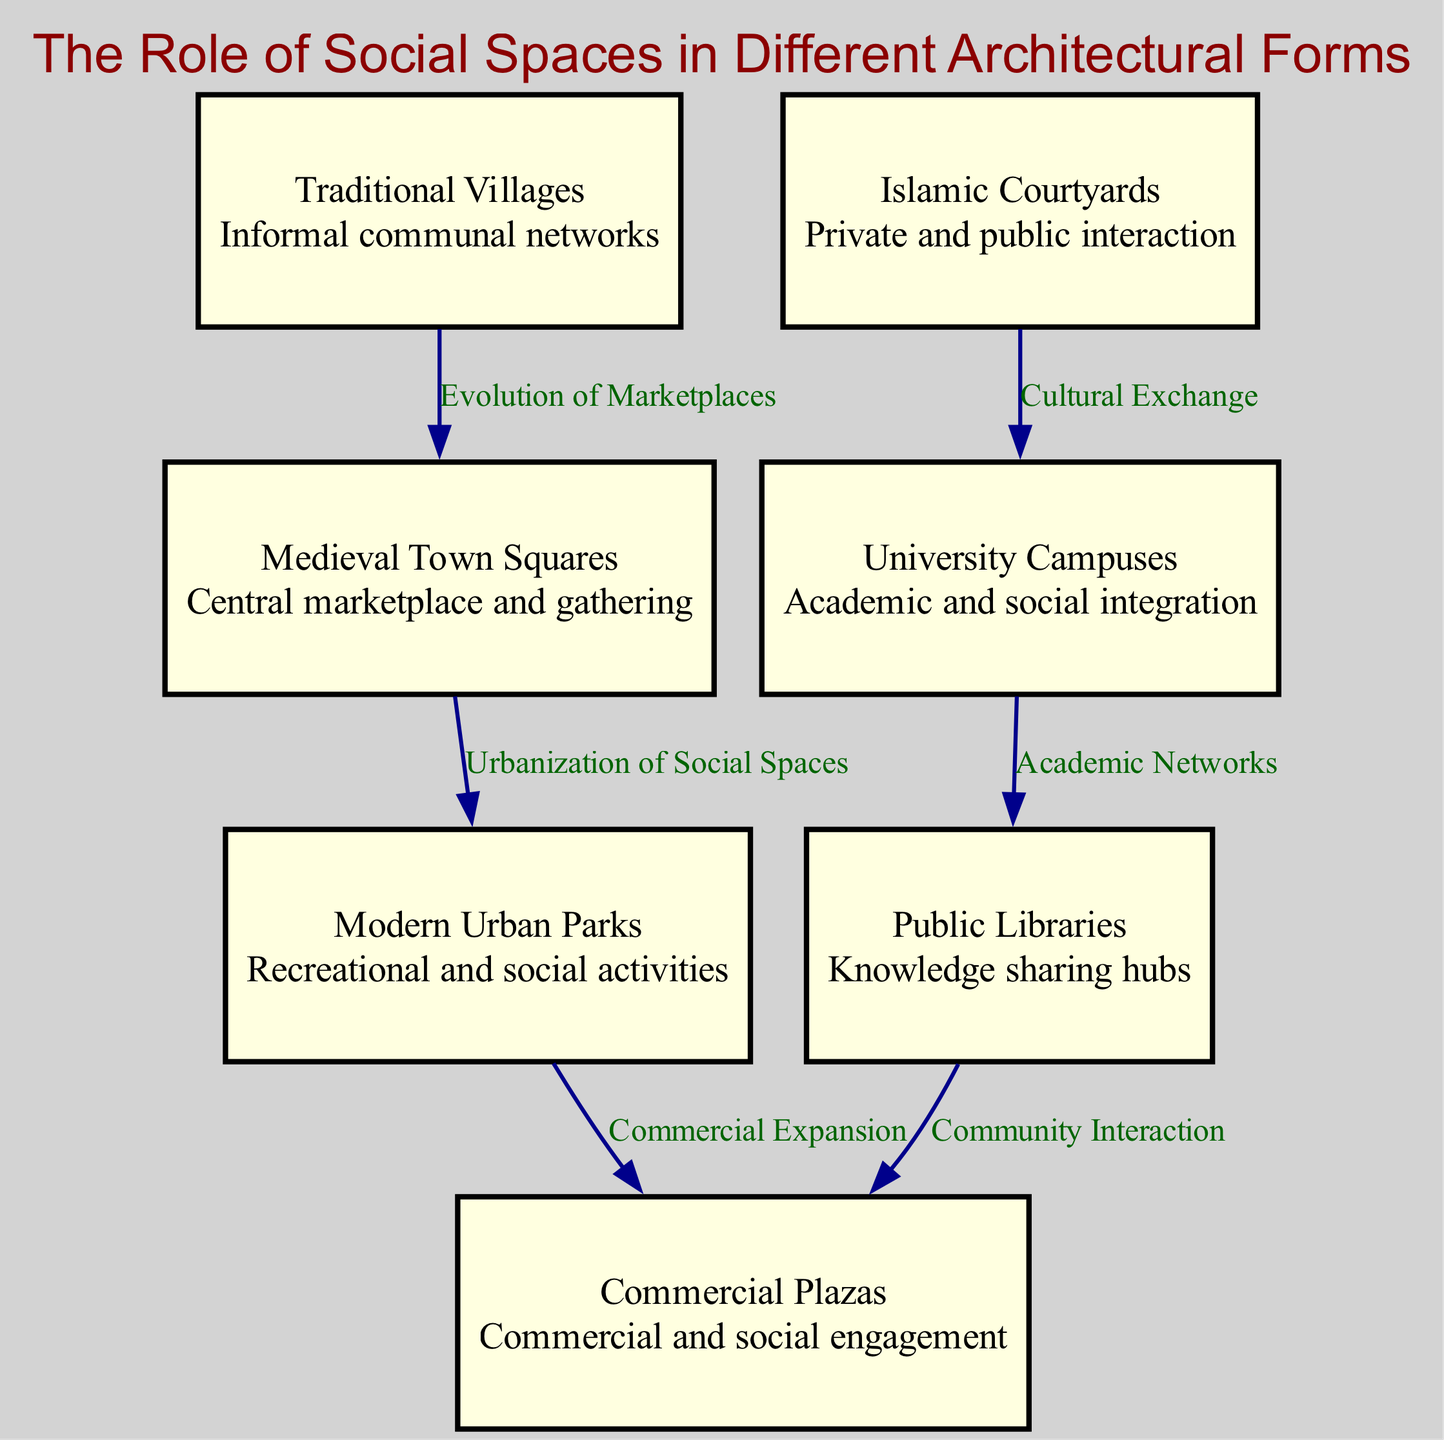What are the different architectural forms represented in the diagram? The diagram includes the following architectural forms: Traditional Villages, Medieval Town Squares, Islamic Courtyards, Modern Urban Parks, University Campuses, Public Libraries, and Commercial Plazas. Each of these forms represents social spaces in different contexts.
Answer: Traditional Villages, Medieval Town Squares, Islamic Courtyards, Modern Urban Parks, University Campuses, Public Libraries, Commercial Plazas How many nodes are in the diagram? The diagram contains a total of 7 nodes, which represent different architectural forms and their associated social spaces. Counting each node listed in the nodes section confirms this total.
Answer: 7 What relationship links Traditional Villages to Medieval Town Squares? The relationship is labeled as "Evolution of Marketplaces", indicating a connection between the shared communal networks of traditional villages and the more centralized gathering spaces of medieval town squares.
Answer: Evolution of Marketplaces Which architectural form acts as a knowledge sharing hub? The Public Libraries node is described as a "Knowledge sharing hub", indicating its primary function in facilitating access to information and learning resources.
Answer: Public Libraries Which architectural forms are linked through the label "Cultural Exchange"? The link labeled "Cultural Exchange" connects Islamic Courtyards and University Campuses, indicating how these spaces foster interactions and sharing of cultural ideas.
Answer: Islamic Courtyards, University Campuses How do Modern Urban Parks relate to Commercial Plazas? The relationship between Modern Urban Parks and Commercial Plazas is represented by the edge labeled "Commercial Expansion". This suggests that social activities in parks may lead to increased commercial development in plazas.
Answer: Commercial Expansion What is the overall role of social spaces in the described architectural forms? Social spaces function as areas for interaction and engagement among people, whether for communal activities, academic integration, commercial engagements, or knowledge sharing, reflecting the social fabric of each architectural form.
Answer: Interaction and engagement 